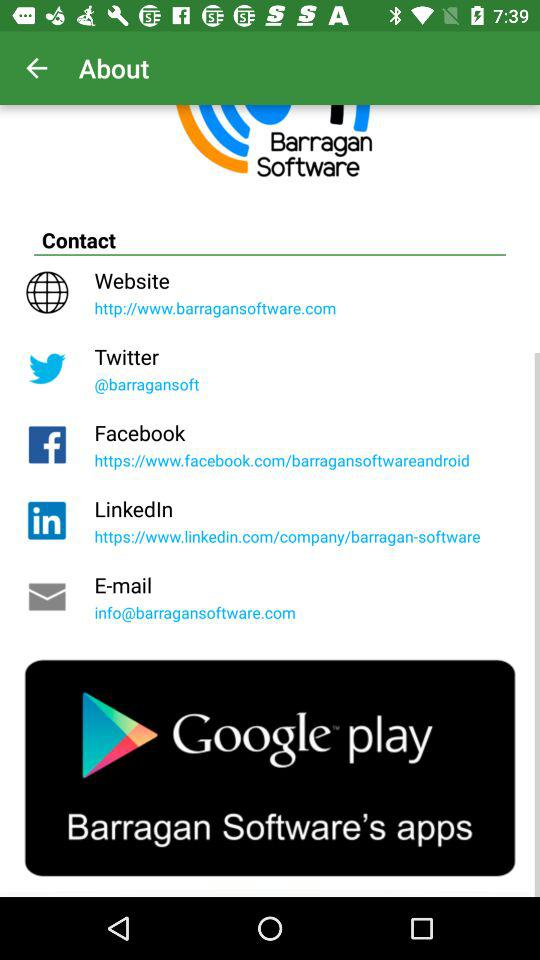What is the name of the company? The name of the company is "Barragan Software". 